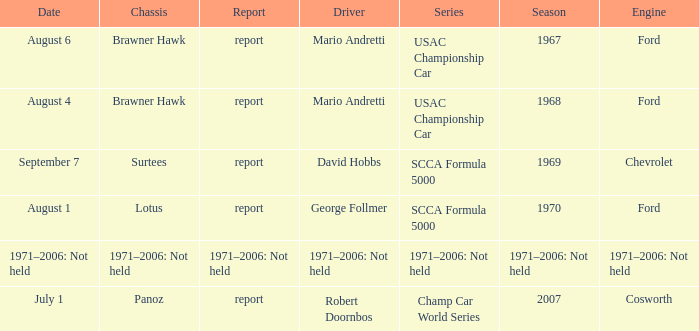Which engine is responsible for the USAC Championship Car? Ford, Ford. 